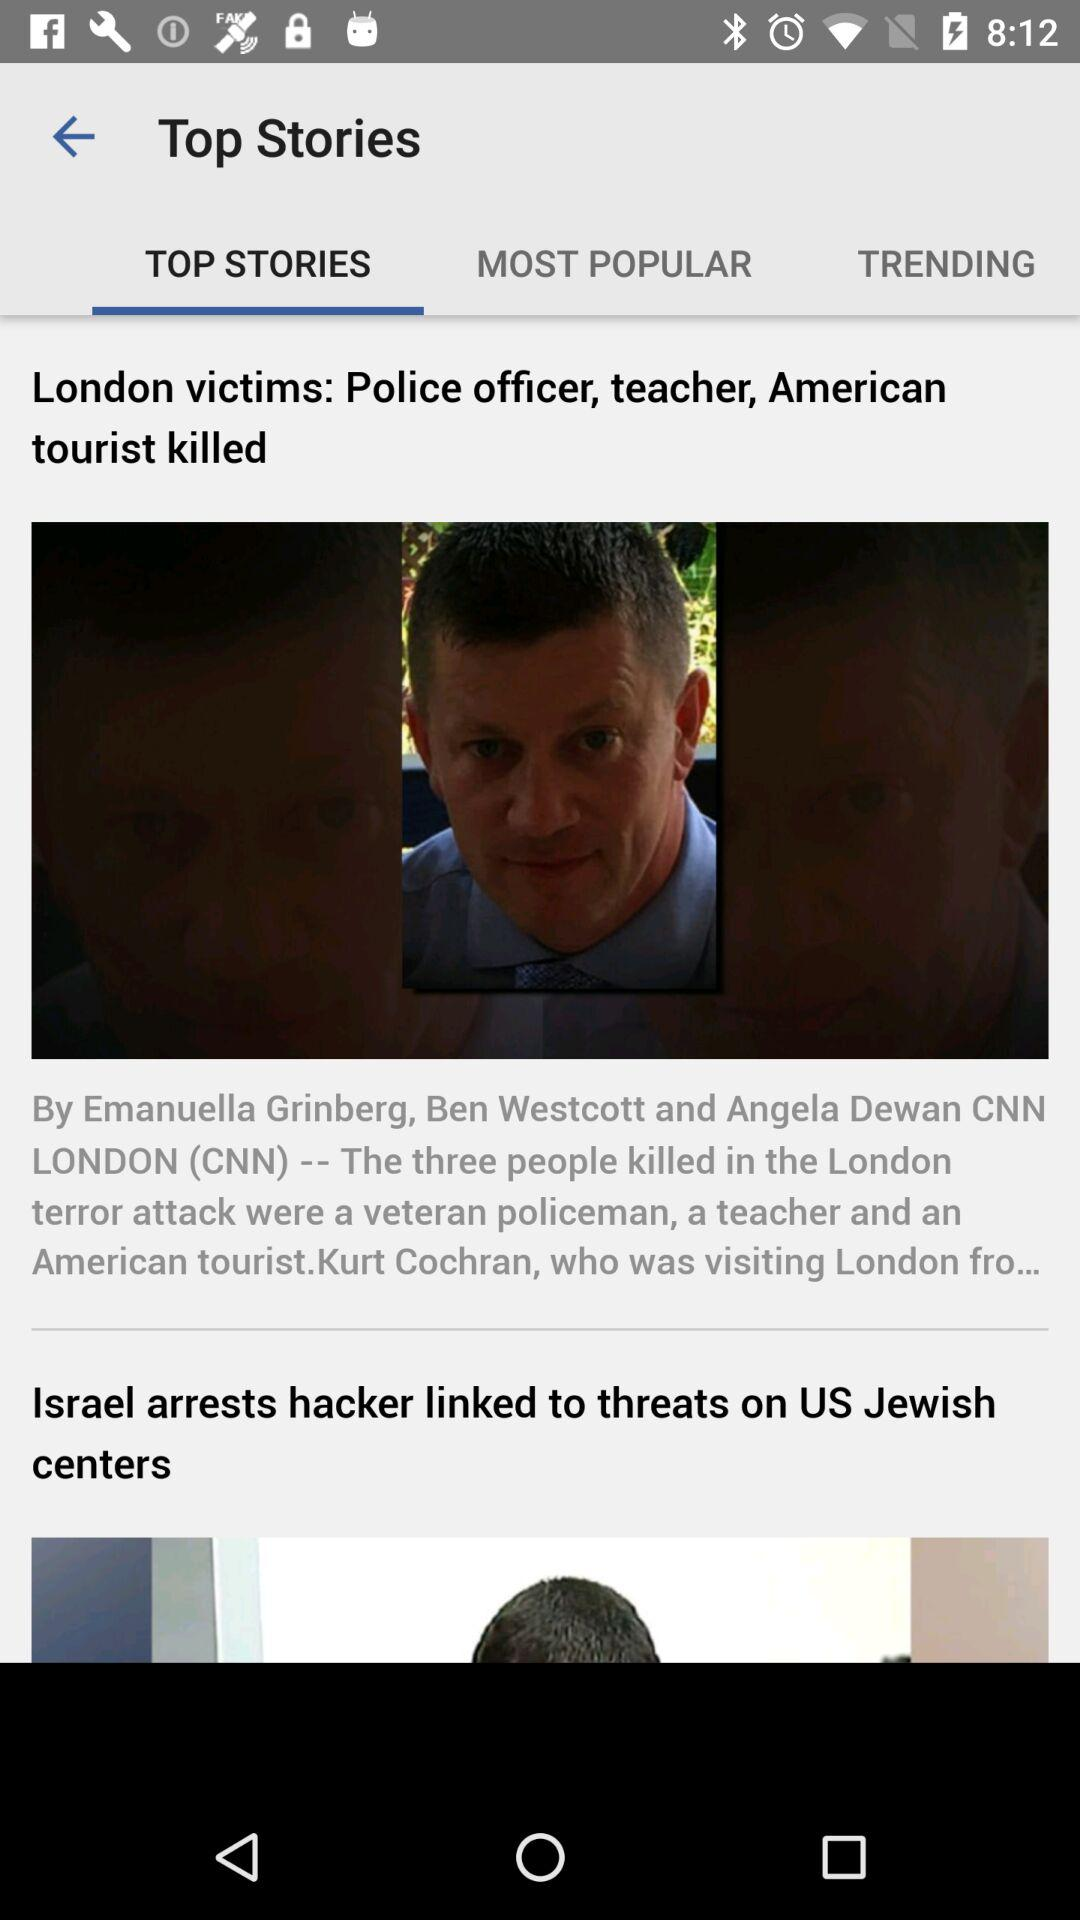Which tab is selected? The selected tab is "TOP STORIES". 